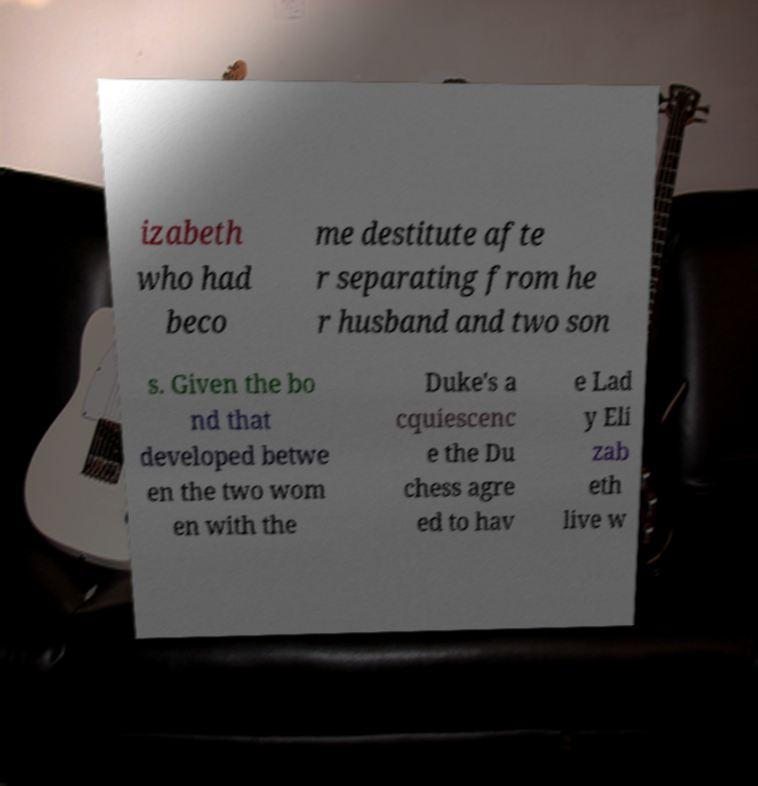Please read and relay the text visible in this image. What does it say? izabeth who had beco me destitute afte r separating from he r husband and two son s. Given the bo nd that developed betwe en the two wom en with the Duke's a cquiescenc e the Du chess agre ed to hav e Lad y Eli zab eth live w 